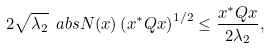<formula> <loc_0><loc_0><loc_500><loc_500>2 \sqrt { \lambda _ { 2 } } \ a b s { N ( x ) } \left ( x ^ { * } Q x \right ) ^ { 1 / 2 } \leq \frac { x ^ { * } Q x } { 2 \lambda _ { 2 } } ,</formula> 